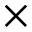<formula> <loc_0><loc_0><loc_500><loc_500>\times</formula> 